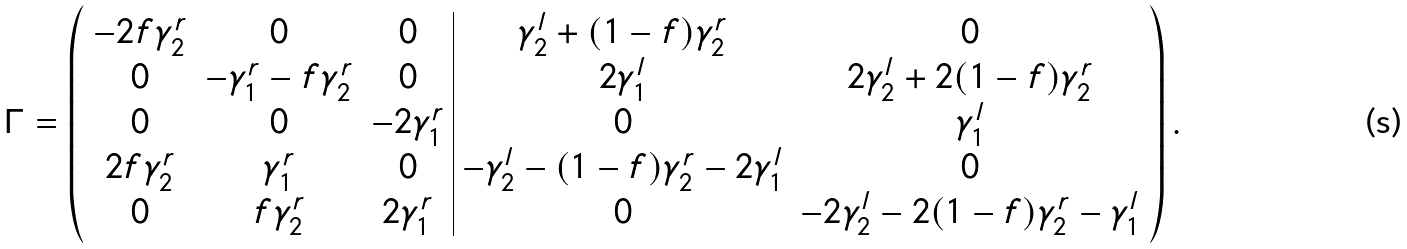<formula> <loc_0><loc_0><loc_500><loc_500>\Gamma = \left ( \begin{array} { c c c | c c } - 2 f \gamma ^ { r } _ { 2 } & 0 & 0 & \gamma ^ { l } _ { 2 } + ( 1 - f ) \gamma ^ { r } _ { 2 } & 0 \\ 0 & - \gamma ^ { r } _ { 1 } - f \gamma ^ { r } _ { 2 } & 0 & 2 \gamma ^ { l } _ { 1 } & 2 \gamma ^ { l } _ { 2 } + 2 ( 1 - f ) \gamma ^ { r } _ { 2 } \\ 0 & 0 & - 2 \gamma ^ { r } _ { 1 } & 0 & \gamma ^ { l } _ { 1 } \\ 2 f \gamma ^ { r } _ { 2 } & \gamma ^ { r } _ { 1 } & 0 & - \gamma ^ { l } _ { 2 } - ( 1 - f ) \gamma ^ { r } _ { 2 } - 2 \gamma ^ { l } _ { 1 } & 0 \\ 0 & f \gamma ^ { r } _ { 2 } & 2 \gamma ^ { r } _ { 1 } & 0 & - 2 \gamma ^ { l } _ { 2 } - 2 ( 1 - f ) \gamma ^ { r } _ { 2 } - \gamma ^ { l } _ { 1 } \end{array} \right ) .</formula> 